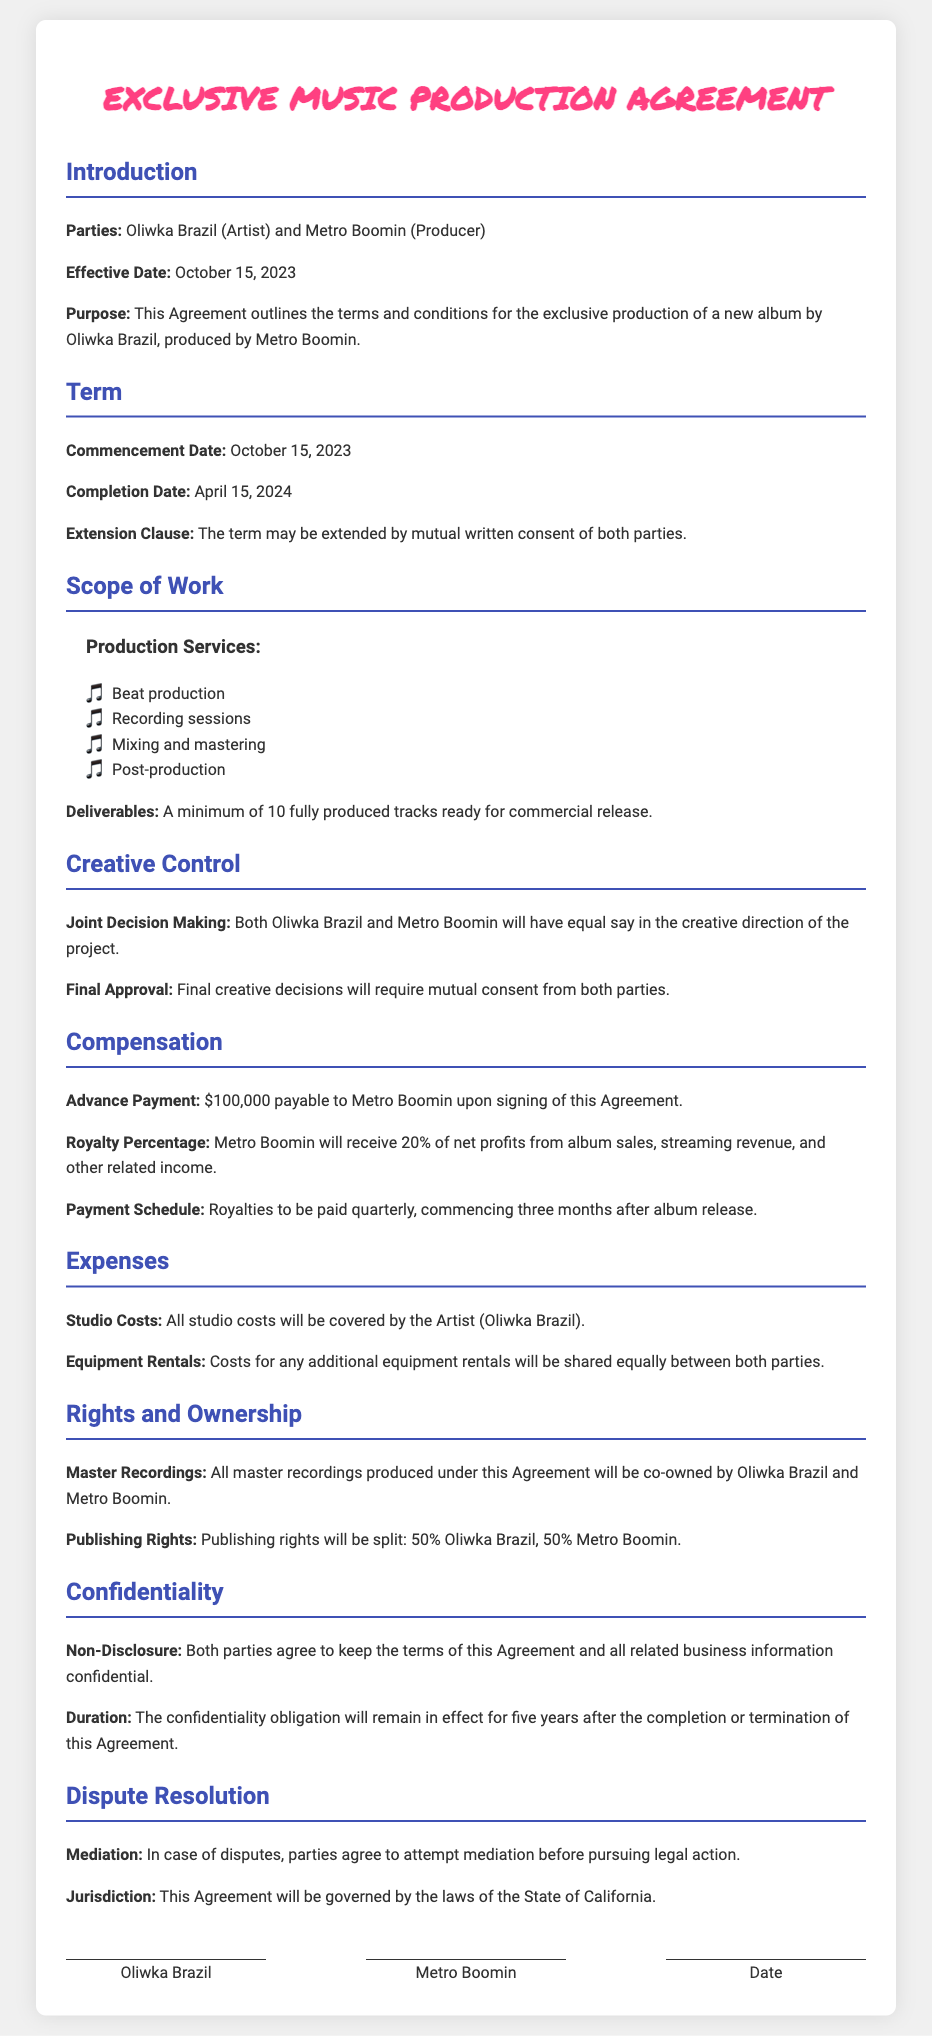What is the effective date of the agreement? The effective date is specified in the Introduction section of the document.
Answer: October 15, 2023 Who are the parties involved in the agreement? The parties are listed in the Introduction section, identifying the Artist and Producer.
Answer: Oliwka Brazil and Metro Boomin What is the completion date of the project? The completion date is mentioned in the Term section of the document.
Answer: April 15, 2024 What percentage of net profits will Metro Boomin receive? This information about compensation can be found in the Compensation section.
Answer: 20% Who will cover the studio costs? The responsibility for studio costs is specified in the Expenses section.
Answer: Oliwka Brazil What will happen if there is a dispute? The procedure for dispute resolution is outlined in the Dispute Resolution section of the document.
Answer: Mediation How many tracks are to be delivered? The number of tracks is mentioned in the Deliverables portion of the Scope of Work section.
Answer: 10 What are the publishing rights split between the parties? The rights distribution is detailed in the Rights and Ownership section of the document.
Answer: 50% Oliwka Brazil, 50% Metro Boomin What is the duration of the confidentiality obligation? The duration is specified in the Confidentiality section of the document.
Answer: Five years 